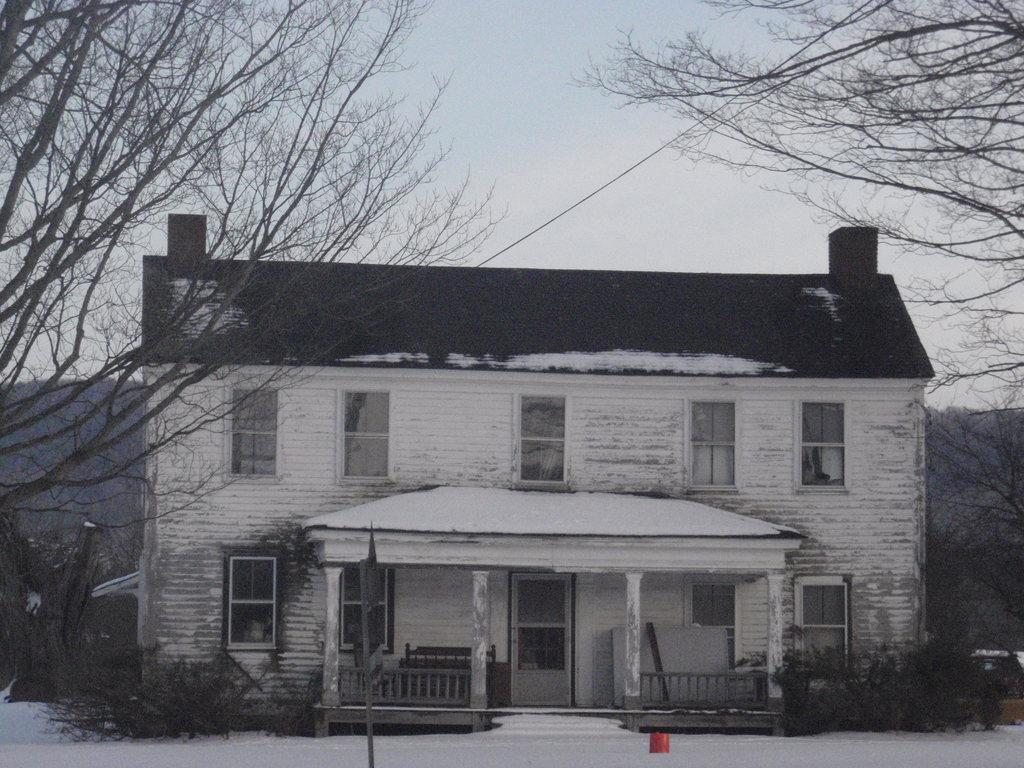In one or two sentences, can you explain what this image depicts? In this picture we can see a building with windows, door, fence, pillars, trees and in the background we can see the sky. 